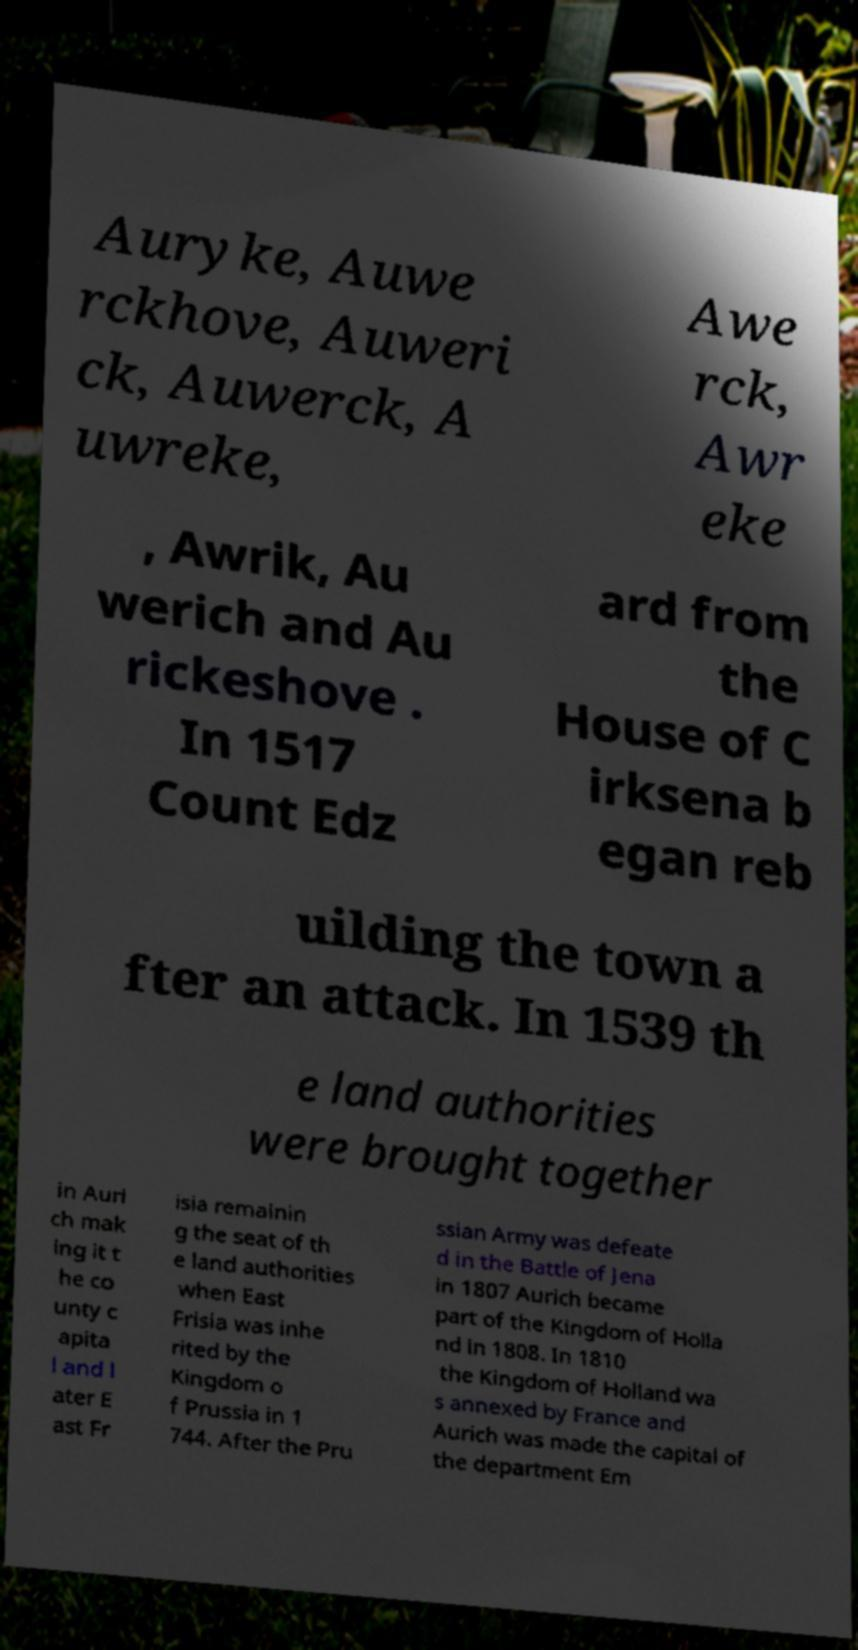There's text embedded in this image that I need extracted. Can you transcribe it verbatim? Auryke, Auwe rckhove, Auweri ck, Auwerck, A uwreke, Awe rck, Awr eke , Awrik, Au werich and Au rickeshove . In 1517 Count Edz ard from the House of C irksena b egan reb uilding the town a fter an attack. In 1539 th e land authorities were brought together in Auri ch mak ing it t he co unty c apita l and l ater E ast Fr isia remainin g the seat of th e land authorities when East Frisia was inhe rited by the Kingdom o f Prussia in 1 744. After the Pru ssian Army was defeate d in the Battle of Jena in 1807 Aurich became part of the Kingdom of Holla nd in 1808. In 1810 the Kingdom of Holland wa s annexed by France and Aurich was made the capital of the department Em 